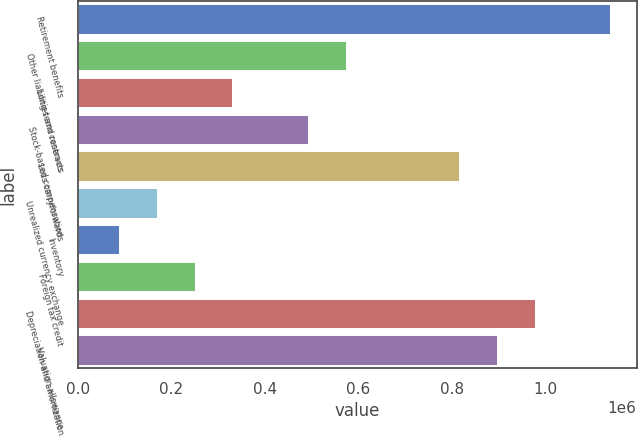Convert chart. <chart><loc_0><loc_0><loc_500><loc_500><bar_chart><fcel>Retirement benefits<fcel>Other liabilities and reserves<fcel>Long-term contracts<fcel>Stock-based compensation<fcel>Loss carryforwards<fcel>Unrealized currency exchange<fcel>Inventory<fcel>Foreign tax credit<fcel>Depreciation and amortization<fcel>Valuation allowance<nl><fcel>1.13863e+06<fcel>573231<fcel>330917<fcel>492460<fcel>815545<fcel>169375<fcel>88603.3<fcel>250146<fcel>977088<fcel>896316<nl></chart> 